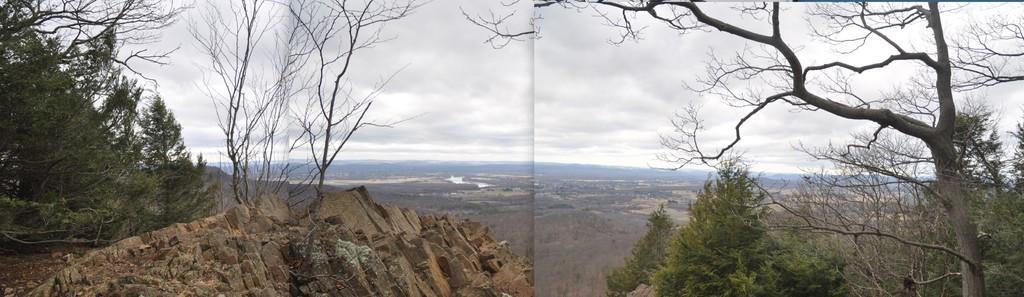Could you give a brief overview of what you see in this image? This is a collage picture and in this picture we can see trees, rocks, mountains and in the background we can see the sky with clouds. 